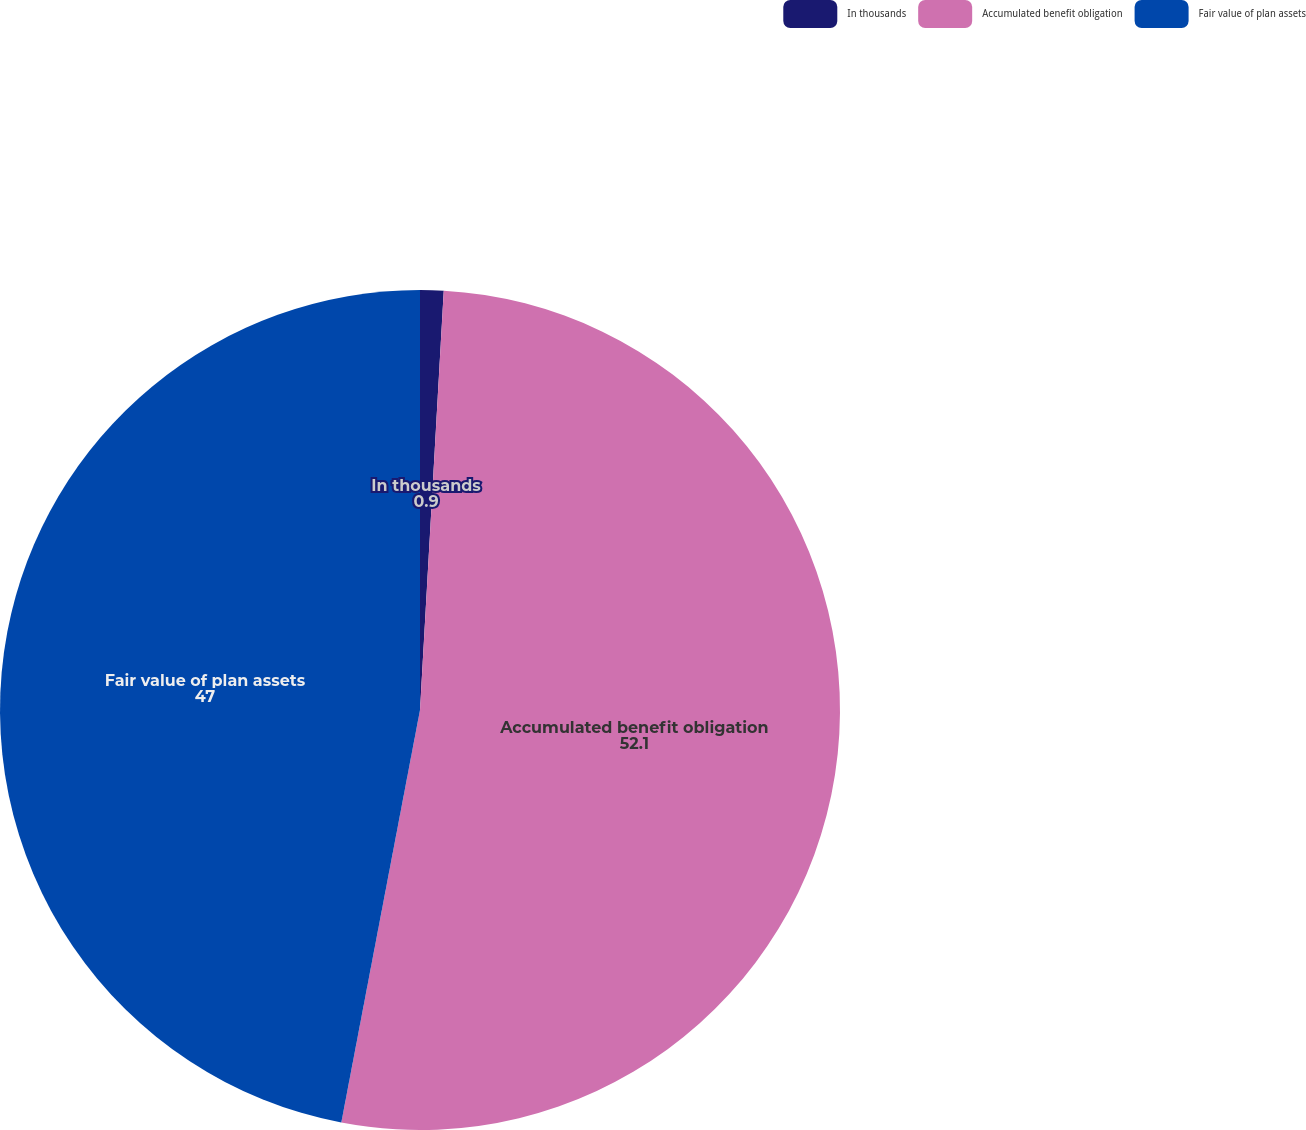Convert chart. <chart><loc_0><loc_0><loc_500><loc_500><pie_chart><fcel>In thousands<fcel>Accumulated benefit obligation<fcel>Fair value of plan assets<nl><fcel>0.9%<fcel>52.1%<fcel>47.0%<nl></chart> 